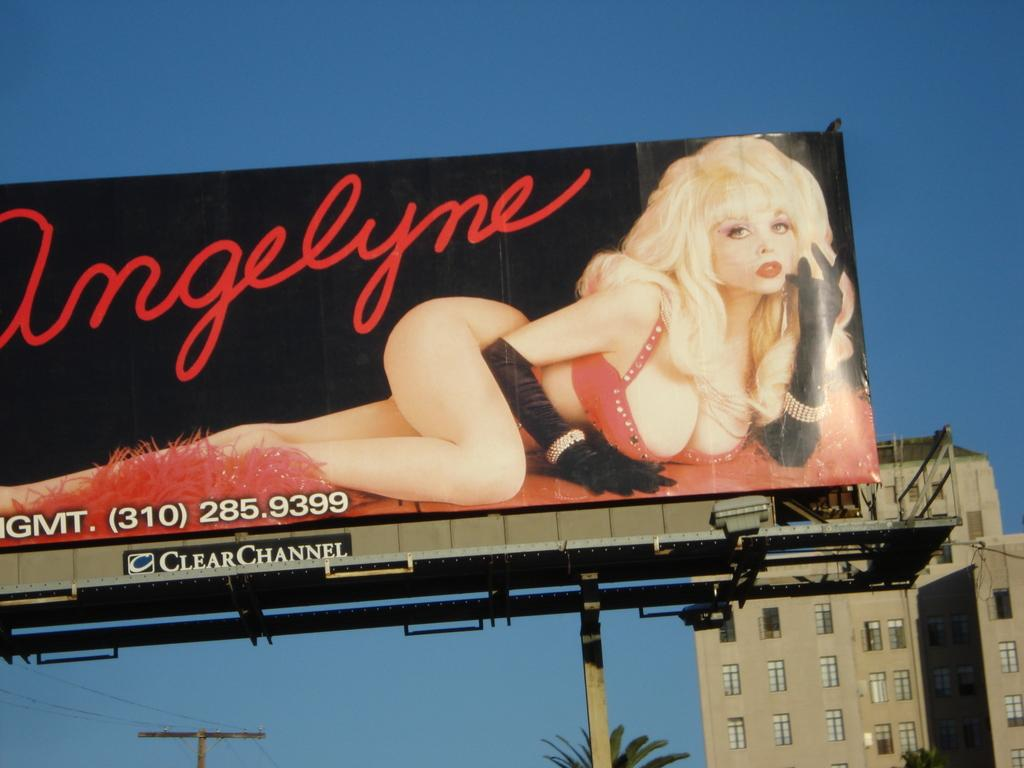<image>
Provide a brief description of the given image. the word angelyne that is on a billboard 